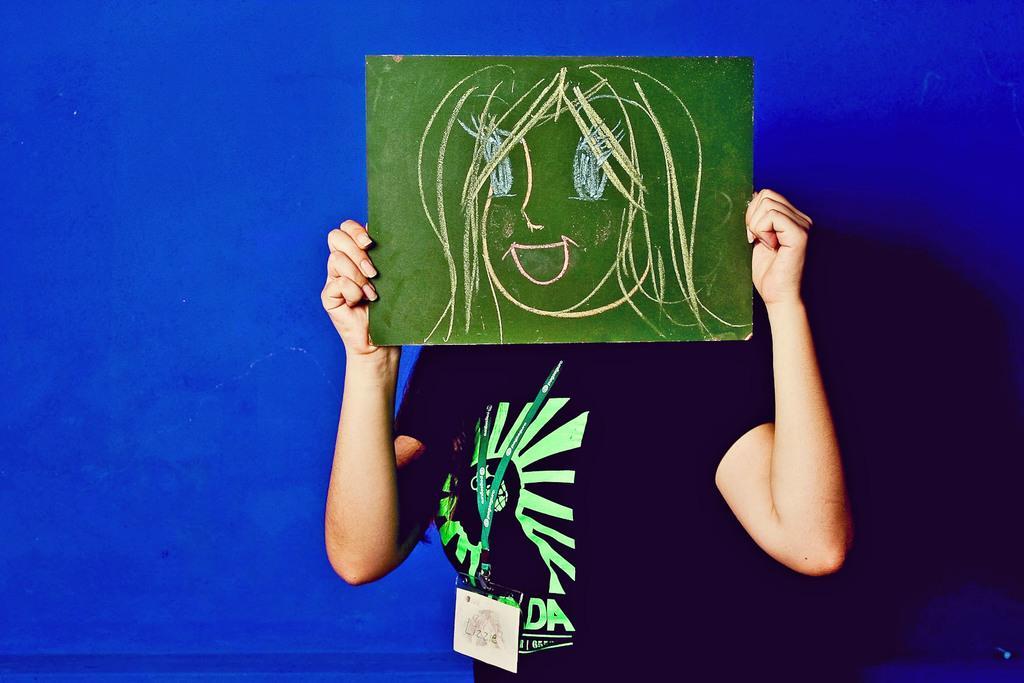How would you summarize this image in a sentence or two? In this image, we can see a person on the blue background. This person is wearing clothes and covering her face with a board contains some drawing. 